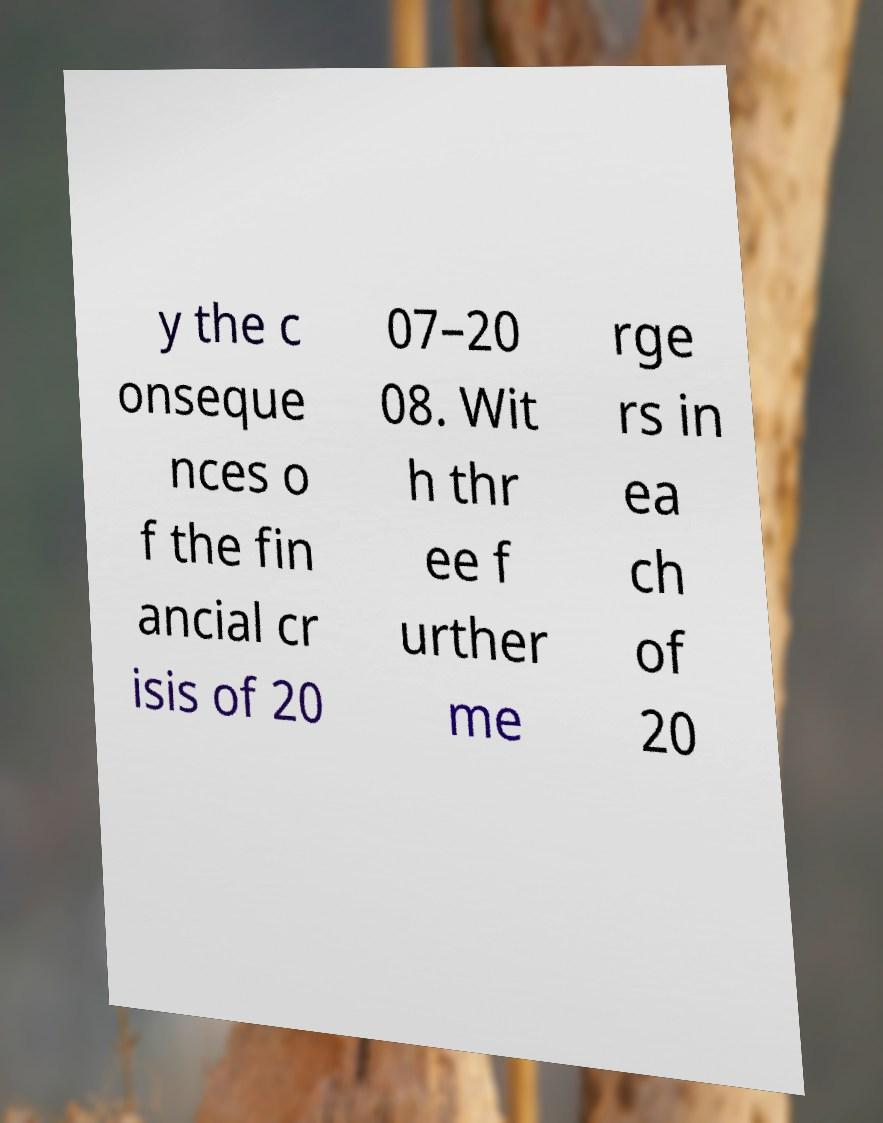Please identify and transcribe the text found in this image. y the c onseque nces o f the fin ancial cr isis of 20 07–20 08. Wit h thr ee f urther me rge rs in ea ch of 20 